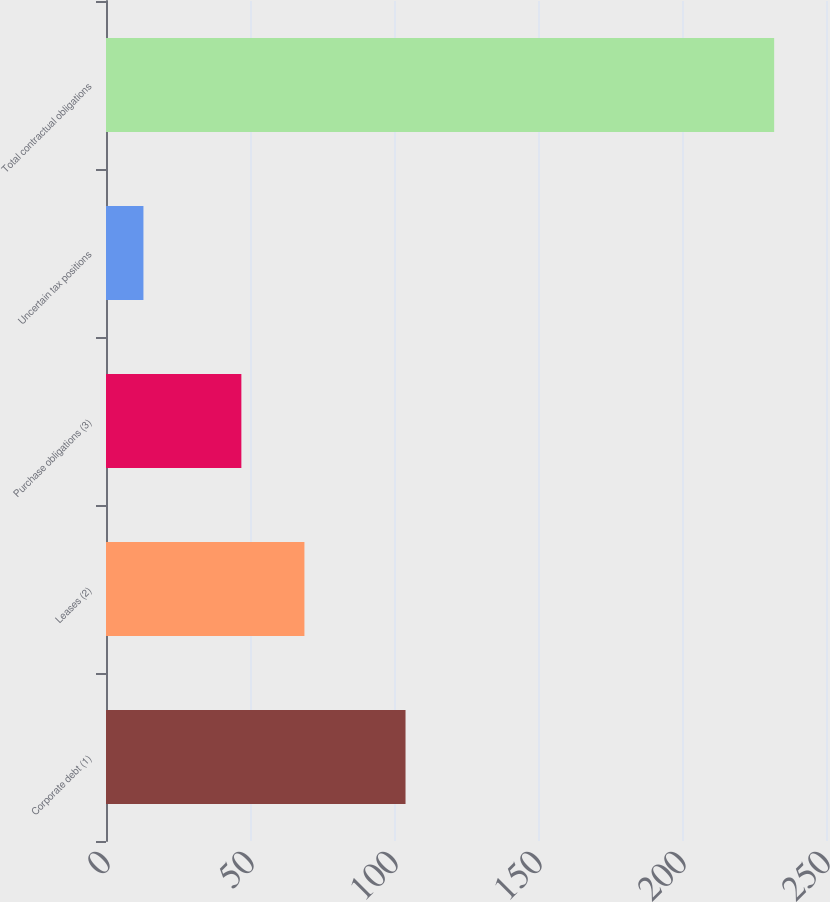Convert chart to OTSL. <chart><loc_0><loc_0><loc_500><loc_500><bar_chart><fcel>Corporate debt (1)<fcel>Leases (2)<fcel>Purchase obligations (3)<fcel>Uncertain tax positions<fcel>Total contractual obligations<nl><fcel>104<fcel>68.9<fcel>47<fcel>13<fcel>232<nl></chart> 